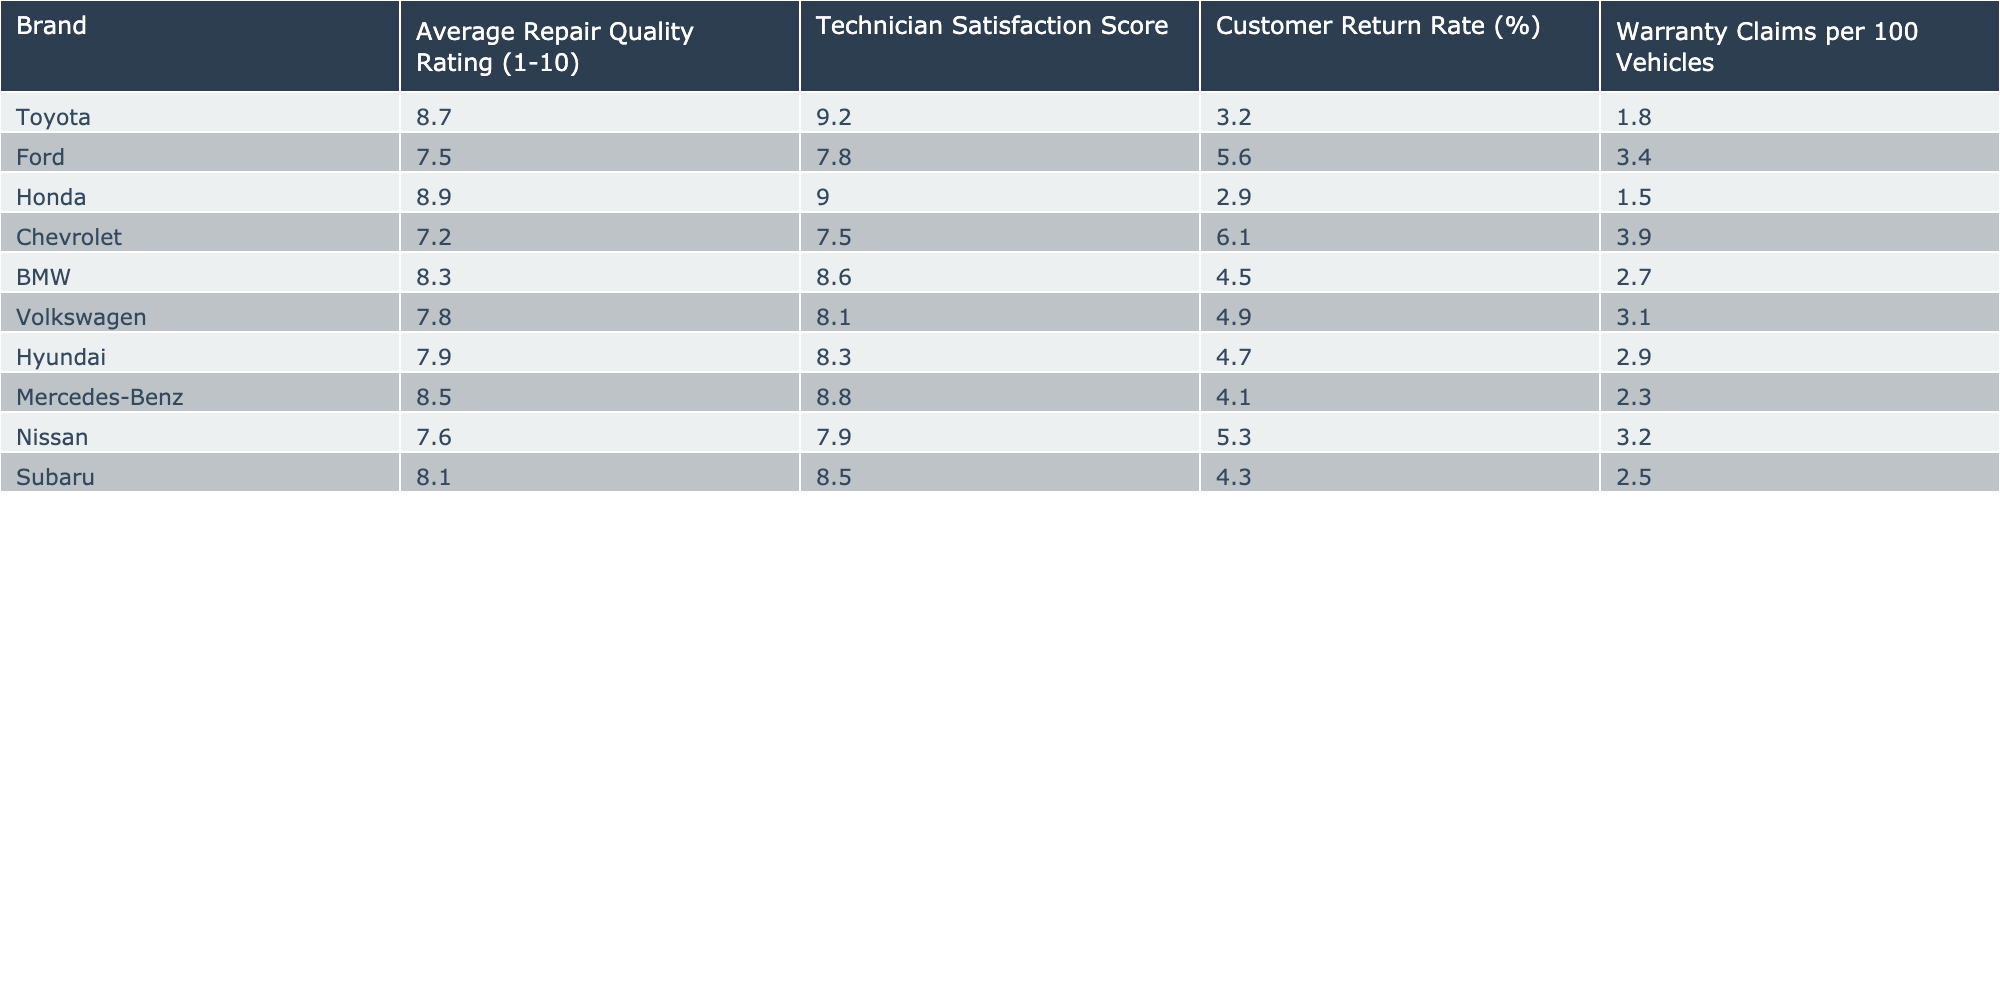What is the average repair quality rating for Toyota? The average repair quality rating for Toyota is provided directly in the table. It shows the figure of 8.7 for Toyota.
Answer: 8.7 Which brand has the highest technician satisfaction score? From the table, Honda has the highest technician satisfaction score listed at 9.0.
Answer: Honda What is the customer return rate for Chevrolet? The table clearly shows that the customer return rate for Chevrolet is 6.1%.
Answer: 6.1% Is the warranty claim rate for BMW less than that for Ford? The warranty claims per 100 vehicles for BMW is 2.7, while for Ford it is 3.4. Since 2.7 is less than 3.4, the statement is true.
Answer: Yes Calculate the average customer return rate for the brands listed in the table. The customer return rates are: 3.2, 5.6, 2.9, 6.1, 4.5, 4.9, 4.7, 4.1, 5.3, and 4.3. Adding these values gives a sum of 51.6, and there are 10 brands. For the average, we divide 51.6 by 10, resulting in 5.16.
Answer: 5.16 Which brand has both a higher average repair quality rating and technician satisfaction score than Mercedes-Benz? The average repair quality rating of Mercedes-Benz is 8.5, and the technician satisfaction score is 8.8. The brands Honda (8.9, 9.0) and Toyota (8.7, 9.2) exceed these figures on both criteria. Hence the answer is Toyota and Honda.
Answer: Toyota and Honda How many brands have a warranty claims rate of less than 3 per 100 vehicles? By checking the warranty claims per 100 vehicles: Toyota (1.8), Honda (1.5), BMW (2.7), Mercedes-Benz (2.3), and Subaru (2.5) all fall below 3. There are 5 such brands.
Answer: 5 What is the difference in average repair quality rating between Honda and Ford? The average repair quality rating for Honda is 8.9 and for Ford it is 7.5. The difference is 8.9 - 7.5 = 1.4.
Answer: 1.4 Does Nissan have higher technician satisfaction than Chevrolet? Nissan has a technician satisfaction score of 7.9, while Chevrolet has a score of 7.5. Since 7.9 is greater than 7.5, the statement is true.
Answer: Yes 